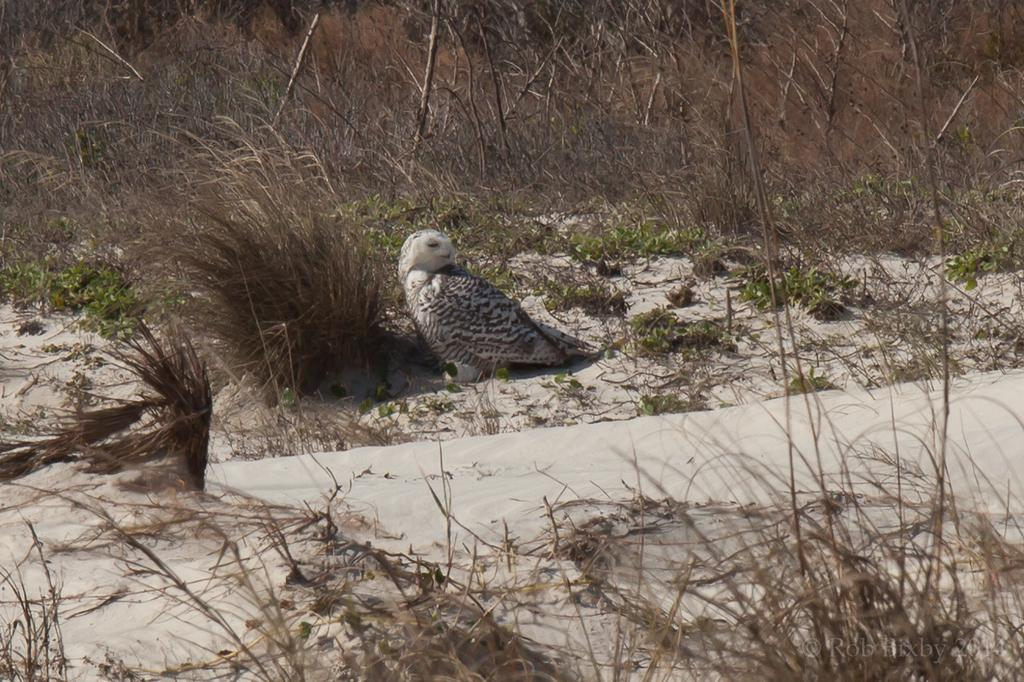What type of animal can be seen in the image? There is a bird in the image. What else is present on the ground in the image? There are plants on the ground in the image. What type of pancake is being served on the basketball court in the image? There is no pancake or basketball court present in the image; it features a bird and plants on the ground. 